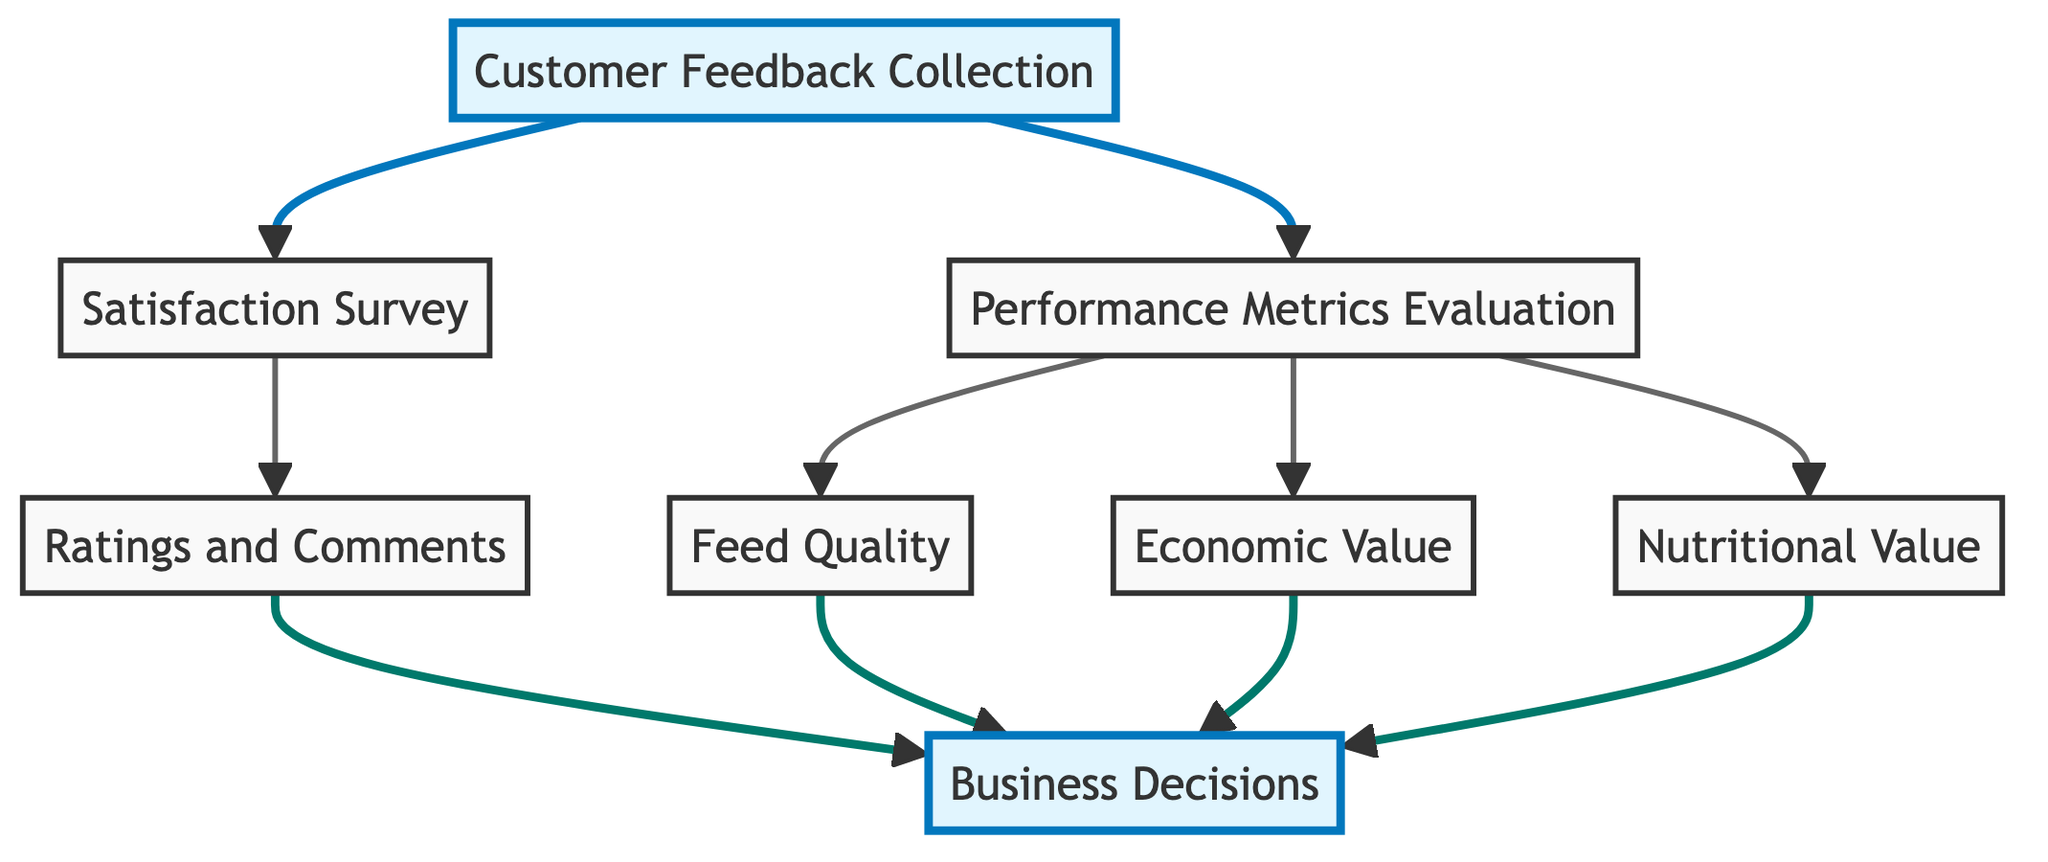What is the first step in the customer feedback flow? The first step, as indicated by the directed graph, is "Customer Feedback Collection." This is the initial node from which all other processes flow.
Answer: Customer Feedback Collection How many nodes are present in the diagram? By counting the nodes listed in the diagram, we find there are a total of eight distinct nodes connected by edges.
Answer: Eight What is generated from the satisfaction survey? The directed graph shows that the satisfaction survey generates "Ratings and Comments," indicating the type of feedback collected after the survey is completed.
Answer: Ratings and Comments Which nodes inform business decisions? The graph illustrates that "Ratings and Comments," "Feed Quality," "Economic Value," and "Nutritional Value" all inform business decisions, as they are the nodes that direct feedback to the final decision-making process.
Answer: Ratings and Comments, Feed Quality, Economic Value, Nutritional Value What evaluates the economic value in the customer feedback flow? According to the directed graph, the "Performance Metrics Evaluation" node directly evaluates "Economic Value," indicating that this assessment is part of the performance metrics process.
Answer: Performance Metrics Evaluation How many edges are there in the diagram? By checking the connections between nodes, we can count the total number of edges; the diagram displays a total of eleven edges linking the various nodes.
Answer: Eleven Which node collects both satisfaction survey and performance metrics? The diagram shows that the "Customer Feedback Collection" node is the one that collects both "Satisfaction Survey" and "Performance Metrics Evaluation," serving as the starting point for these processes.
Answer: Customer Feedback Collection What flows from performance metrics evaluation to feed quality? The directed graph indicates a direct evaluation relationship where "Performance Metrics Evaluation" evaluates "Feed Quality," leading to insights about the quality of the feeds.
Answer: Feed Quality Which node connects to business decisions via ratings and comments? The connection from the node "Ratings and Comments" to "Business Decisions" indicates that the feedback collected is used to influence and inform decisions made in business strategies.
Answer: Business Decisions 